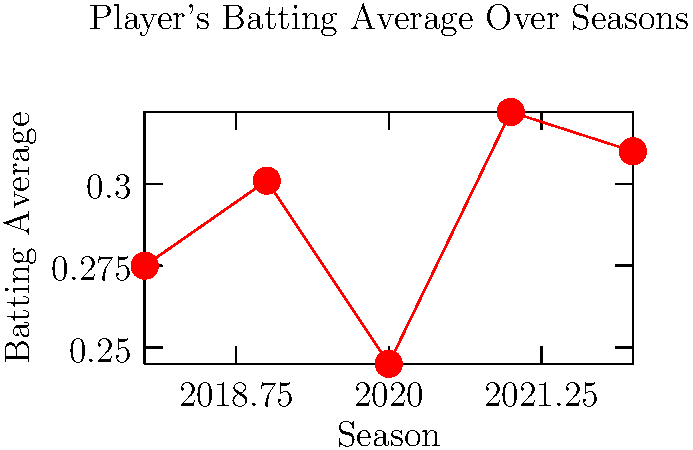Analyzing the line graph of a player's batting average across five seasons (2018-2022), which season showed the most significant improvement in performance compared to the previous year? To determine the season with the most significant improvement, we need to calculate the year-over-year changes in batting average:

1. 2018 to 2019: $0.301 - 0.275 = 0.026$ increase
2. 2019 to 2020: $0.245 - 0.301 = -0.056$ decrease
3. 2020 to 2021: $0.322 - 0.245 = 0.077$ increase
4. 2021 to 2022: $0.310 - 0.322 = -0.012$ decrease

The largest positive change occurred from 2020 to 2021, with an increase of 0.077 in batting average. This represents the most significant improvement in performance compared to the previous year.

As a college baseball scout, this kind of analysis is crucial for identifying players who show potential for rapid improvement and consistency in their performance.
Answer: 2021 